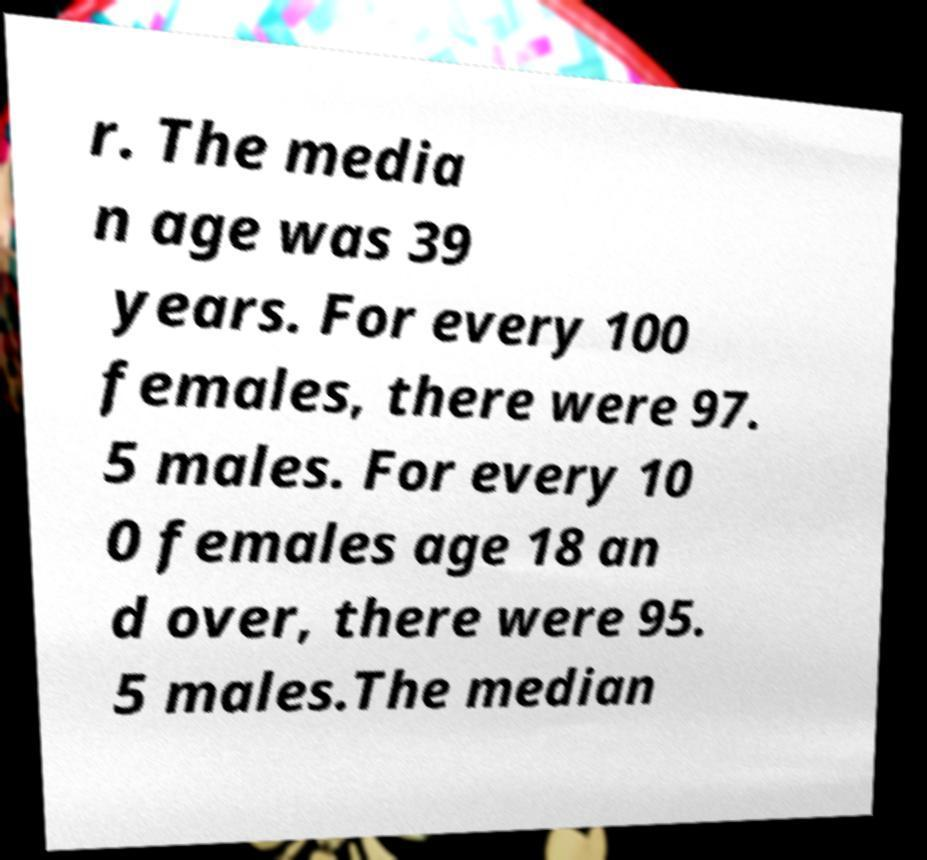What messages or text are displayed in this image? I need them in a readable, typed format. r. The media n age was 39 years. For every 100 females, there were 97. 5 males. For every 10 0 females age 18 an d over, there were 95. 5 males.The median 